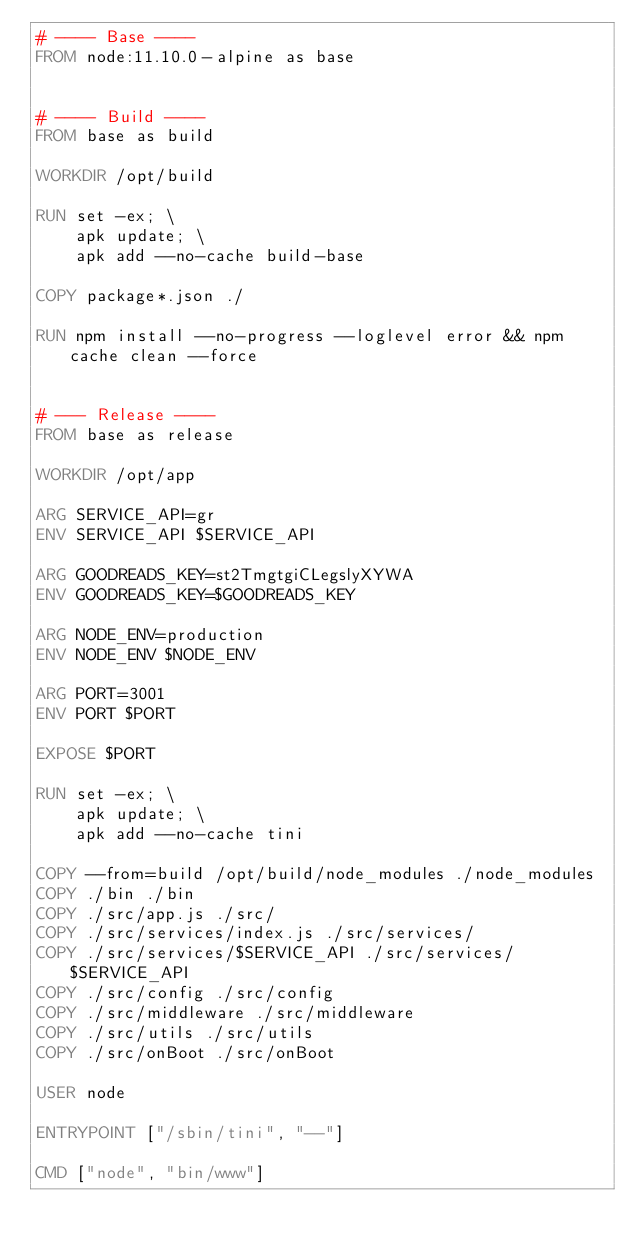Convert code to text. <code><loc_0><loc_0><loc_500><loc_500><_Dockerfile_># ---- Base ----
FROM node:11.10.0-alpine as base


# ---- Build ----
FROM base as build

WORKDIR /opt/build

RUN set -ex; \
    apk update; \
    apk add --no-cache build-base

COPY package*.json ./

RUN npm install --no-progress --loglevel error && npm cache clean --force


# --- Release ----
FROM base as release

WORKDIR /opt/app

ARG SERVICE_API=gr
ENV SERVICE_API $SERVICE_API

ARG GOODREADS_KEY=st2TmgtgiCLegslyXYWA
ENV GOODREADS_KEY=$GOODREADS_KEY

ARG NODE_ENV=production
ENV NODE_ENV $NODE_ENV

ARG PORT=3001
ENV PORT $PORT

EXPOSE $PORT

RUN set -ex; \
    apk update; \
    apk add --no-cache tini

COPY --from=build /opt/build/node_modules ./node_modules
COPY ./bin ./bin
COPY ./src/app.js ./src/
COPY ./src/services/index.js ./src/services/
COPY ./src/services/$SERVICE_API ./src/services/$SERVICE_API
COPY ./src/config ./src/config
COPY ./src/middleware ./src/middleware
COPY ./src/utils ./src/utils
COPY ./src/onBoot ./src/onBoot

USER node

ENTRYPOINT ["/sbin/tini", "--"]

CMD ["node", "bin/www"]
</code> 